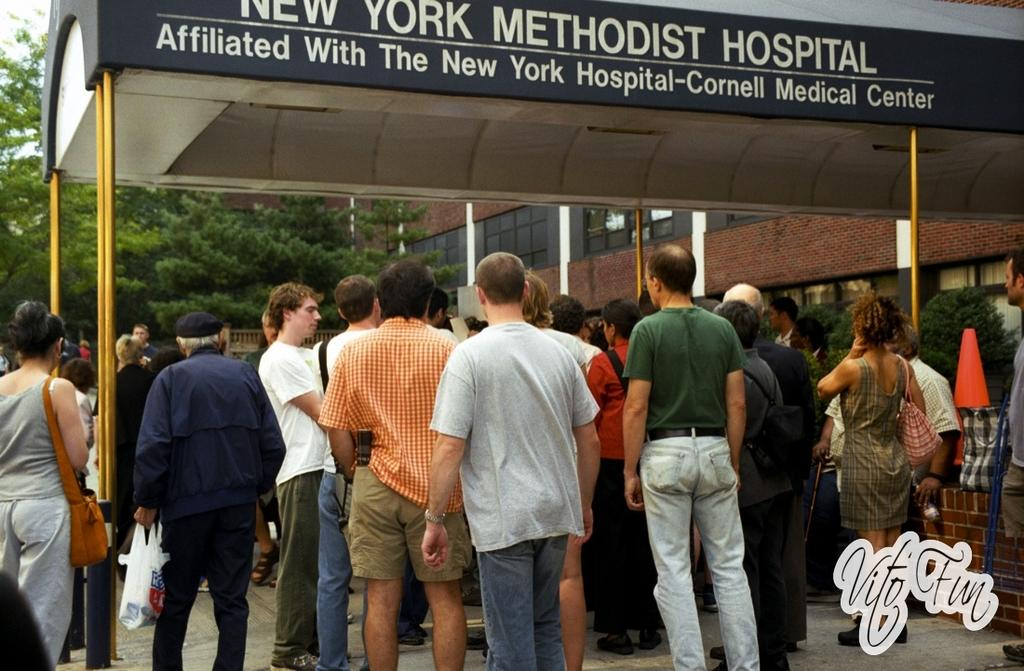What type of structure is visible in the image? There is a shelter in the image. What object can be seen on the right side of the image? There is a divider cone on the right side of the image. What type of vegetation is in front of a building in the image? There are trees in front of a building in the image. How many oranges are on the crate in the image? There is no crate or oranges present in the image. What type of balls are being used in the game in the image? There is no game or balls present in the image. 